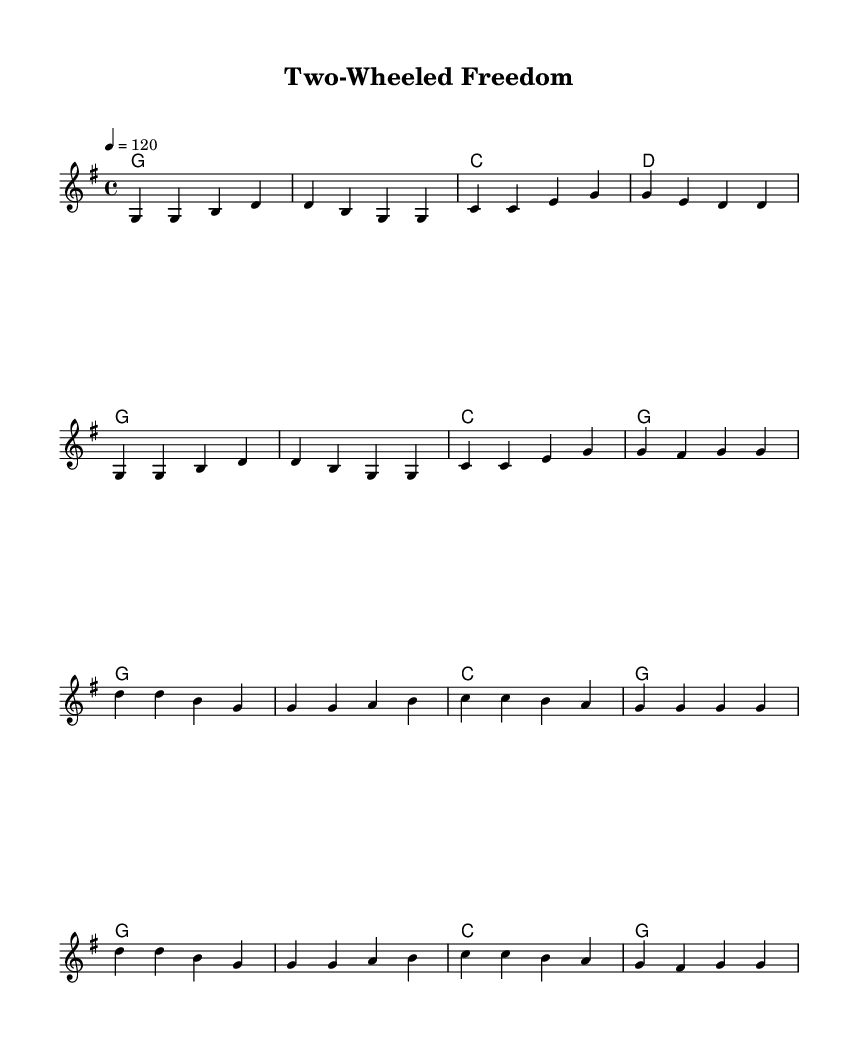What is the key signature of this music? The key signature is G major, which has one sharp (F#). This can be identified from the key signature marking at the beginning of the staff.
Answer: G major What is the time signature of this music? The time signature is 4/4, which indicates there are four beats in each measure and the quarter note receives one beat. This is indicated by the '4/4' marking at the beginning of the score.
Answer: 4/4 What is the tempo marking of this music? The tempo marking is 120 beats per minute, as indicated by the notation “4 = 120” found at the beginning of the score, which is standard for a moderate tempo.
Answer: 120 How many measures are in the verse section? The verse section consists of 8 measures, identifiable by counting the individual measures from the beginning of the melody until the transition to the chorus.
Answer: 8 What are the primary chords used in the chorus? The primary chords in the chorus are G and C, as indicated by the chord names written above the melody during the chorus section. The recurring G and C chords highlight the harmonic focus of the chorus.
Answer: G, C Which musical style does this piece represent? This piece represents Country Rock as it features themes of freedom associated with motorcycle culture and road trips, common in the genre. Although the sheet music does not explicitly state the genre, the title and overall structure suggest this classification.
Answer: Country Rock What is the highest note in the melody? The highest note in the melody is D4, which can be observed at the start of the chorus section. It is the first note of the chorus and indicates the peak pitch in the context of the song.
Answer: D4 